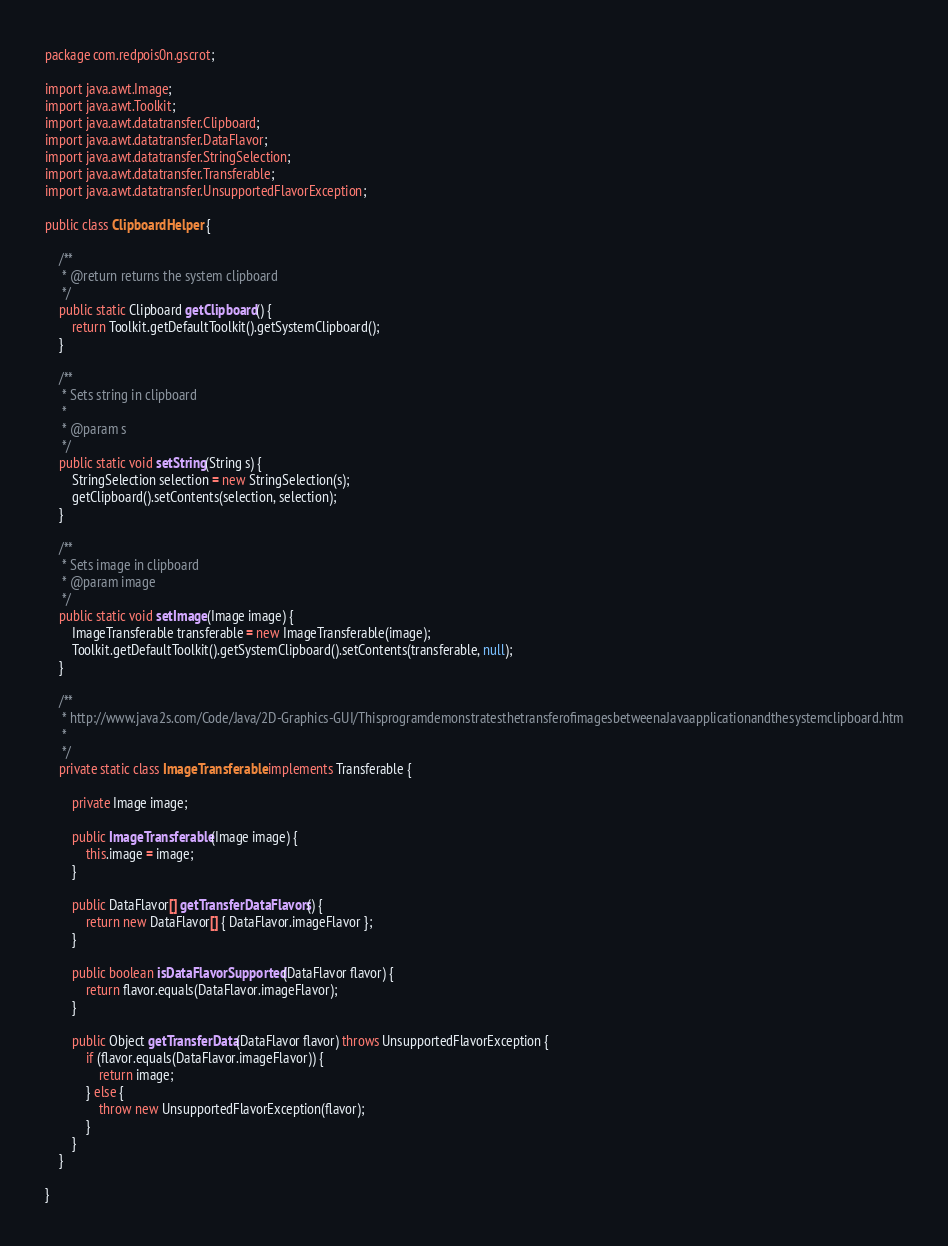Convert code to text. <code><loc_0><loc_0><loc_500><loc_500><_Java_>package com.redpois0n.gscrot;

import java.awt.Image;
import java.awt.Toolkit;
import java.awt.datatransfer.Clipboard;
import java.awt.datatransfer.DataFlavor;
import java.awt.datatransfer.StringSelection;
import java.awt.datatransfer.Transferable;
import java.awt.datatransfer.UnsupportedFlavorException;

public class ClipboardHelper {

	/**
	 * @return returns the system clipboard
	 */
	public static Clipboard getClipboard() {
		return Toolkit.getDefaultToolkit().getSystemClipboard();
	}

	/**
	 * Sets string in clipboard
	 * 
	 * @param s
	 */
	public static void setString(String s) {
		StringSelection selection = new StringSelection(s);
		getClipboard().setContents(selection, selection);
	}

	/**
	 * Sets image in clipboard
	 * @param image
	 */
	public static void setImage(Image image) {
		ImageTransferable transferable = new ImageTransferable(image);
		Toolkit.getDefaultToolkit().getSystemClipboard().setContents(transferable, null);
	}

	/**
	 * http://www.java2s.com/Code/Java/2D-Graphics-GUI/ThisprogramdemonstratesthetransferofimagesbetweenaJavaapplicationandthesystemclipboard.htm
	 *
	 */
	private static class ImageTransferable implements Transferable {

		private Image image;

		public ImageTransferable(Image image) {
			this.image = image;
		}

		public DataFlavor[] getTransferDataFlavors() {
			return new DataFlavor[] { DataFlavor.imageFlavor };
		}

		public boolean isDataFlavorSupported(DataFlavor flavor) {
			return flavor.equals(DataFlavor.imageFlavor);
		}

		public Object getTransferData(DataFlavor flavor) throws UnsupportedFlavorException {
			if (flavor.equals(DataFlavor.imageFlavor)) {
				return image;
			} else {
				throw new UnsupportedFlavorException(flavor);
			}
		}
	}

}
</code> 